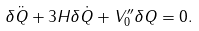Convert formula to latex. <formula><loc_0><loc_0><loc_500><loc_500>\delta \ddot { Q } + 3 H \delta \dot { Q } + V _ { 0 } ^ { \prime \prime } \delta Q = 0 .</formula> 